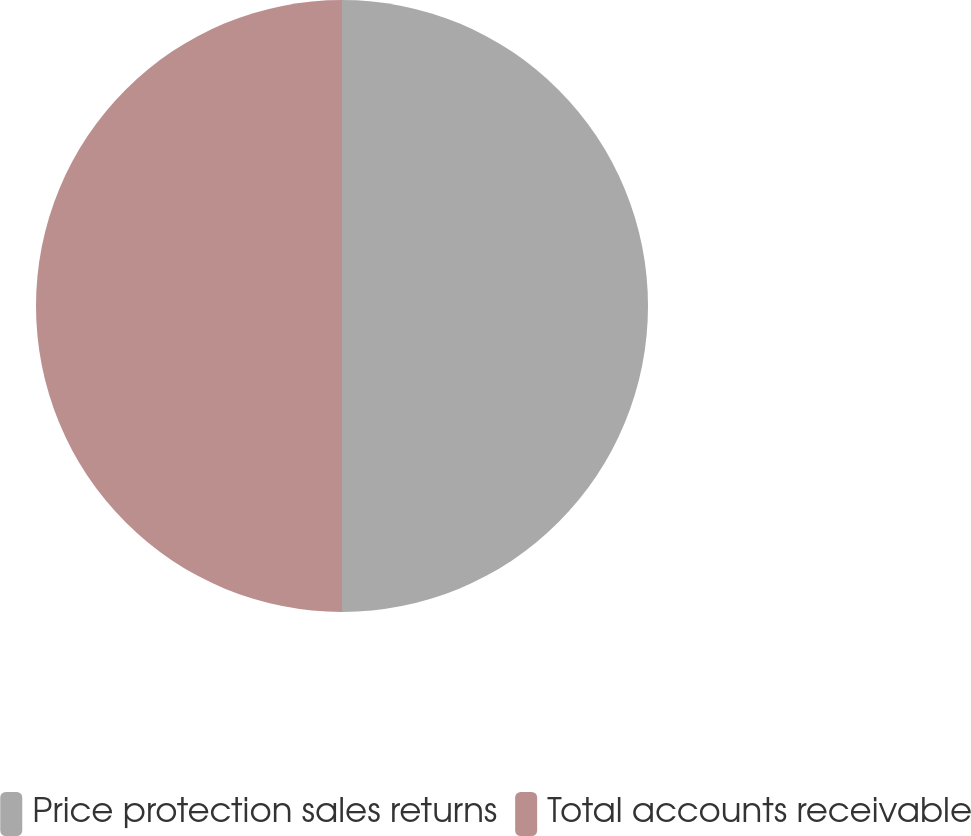<chart> <loc_0><loc_0><loc_500><loc_500><pie_chart><fcel>Price protection sales returns<fcel>Total accounts receivable<nl><fcel>50.0%<fcel>50.0%<nl></chart> 